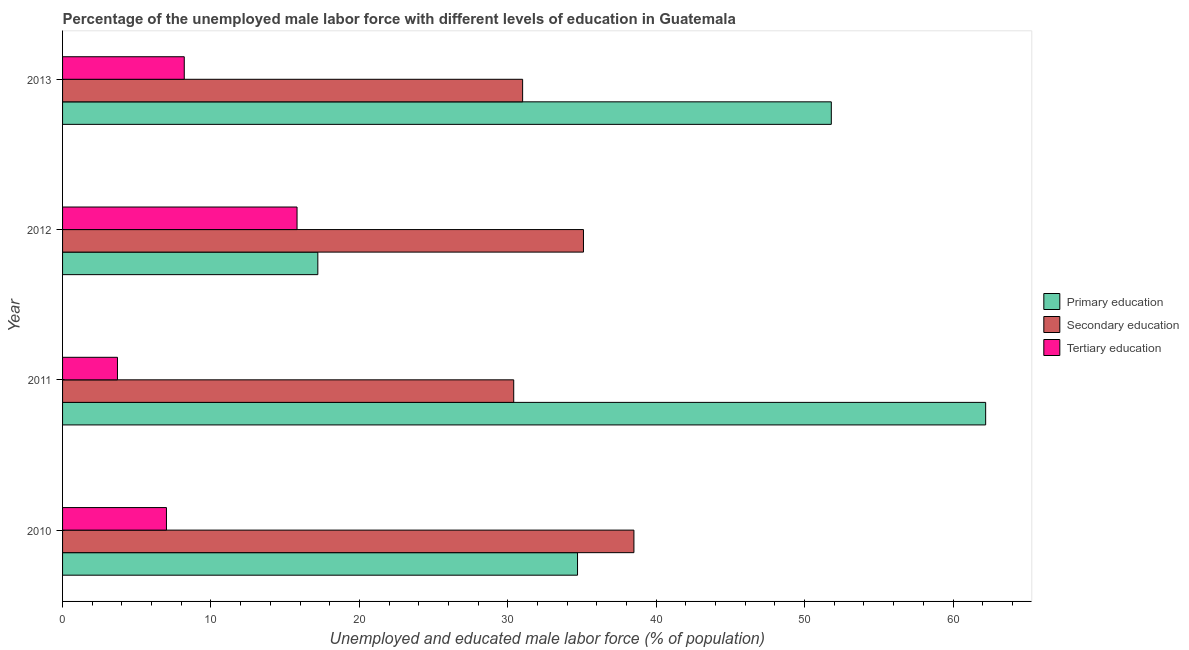How many groups of bars are there?
Offer a terse response. 4. Are the number of bars on each tick of the Y-axis equal?
Offer a very short reply. Yes. How many bars are there on the 1st tick from the bottom?
Ensure brevity in your answer.  3. In how many cases, is the number of bars for a given year not equal to the number of legend labels?
Provide a succinct answer. 0. What is the percentage of male labor force who received secondary education in 2011?
Provide a succinct answer. 30.4. Across all years, what is the maximum percentage of male labor force who received secondary education?
Your response must be concise. 38.5. Across all years, what is the minimum percentage of male labor force who received primary education?
Provide a succinct answer. 17.2. In which year was the percentage of male labor force who received primary education maximum?
Provide a short and direct response. 2011. In which year was the percentage of male labor force who received primary education minimum?
Give a very brief answer. 2012. What is the total percentage of male labor force who received secondary education in the graph?
Your answer should be compact. 135. What is the difference between the percentage of male labor force who received secondary education in 2011 and that in 2013?
Your answer should be very brief. -0.6. What is the difference between the percentage of male labor force who received secondary education in 2011 and the percentage of male labor force who received tertiary education in 2012?
Provide a short and direct response. 14.6. What is the average percentage of male labor force who received primary education per year?
Provide a short and direct response. 41.48. In the year 2013, what is the difference between the percentage of male labor force who received secondary education and percentage of male labor force who received primary education?
Your answer should be compact. -20.8. What is the ratio of the percentage of male labor force who received tertiary education in 2011 to that in 2013?
Keep it short and to the point. 0.45. Is the percentage of male labor force who received secondary education in 2011 less than that in 2013?
Ensure brevity in your answer.  Yes. Is the difference between the percentage of male labor force who received secondary education in 2011 and 2013 greater than the difference between the percentage of male labor force who received primary education in 2011 and 2013?
Give a very brief answer. No. What is the difference between the highest and the second highest percentage of male labor force who received tertiary education?
Provide a succinct answer. 7.6. How many bars are there?
Offer a terse response. 12. How many years are there in the graph?
Offer a terse response. 4. What is the difference between two consecutive major ticks on the X-axis?
Provide a succinct answer. 10. Does the graph contain any zero values?
Provide a succinct answer. No. How many legend labels are there?
Give a very brief answer. 3. What is the title of the graph?
Keep it short and to the point. Percentage of the unemployed male labor force with different levels of education in Guatemala. What is the label or title of the X-axis?
Offer a terse response. Unemployed and educated male labor force (% of population). What is the Unemployed and educated male labor force (% of population) of Primary education in 2010?
Provide a succinct answer. 34.7. What is the Unemployed and educated male labor force (% of population) of Secondary education in 2010?
Offer a terse response. 38.5. What is the Unemployed and educated male labor force (% of population) of Tertiary education in 2010?
Ensure brevity in your answer.  7. What is the Unemployed and educated male labor force (% of population) of Primary education in 2011?
Offer a terse response. 62.2. What is the Unemployed and educated male labor force (% of population) in Secondary education in 2011?
Your answer should be very brief. 30.4. What is the Unemployed and educated male labor force (% of population) of Tertiary education in 2011?
Keep it short and to the point. 3.7. What is the Unemployed and educated male labor force (% of population) of Primary education in 2012?
Offer a terse response. 17.2. What is the Unemployed and educated male labor force (% of population) in Secondary education in 2012?
Offer a very short reply. 35.1. What is the Unemployed and educated male labor force (% of population) in Tertiary education in 2012?
Make the answer very short. 15.8. What is the Unemployed and educated male labor force (% of population) of Primary education in 2013?
Make the answer very short. 51.8. What is the Unemployed and educated male labor force (% of population) in Secondary education in 2013?
Your response must be concise. 31. What is the Unemployed and educated male labor force (% of population) of Tertiary education in 2013?
Ensure brevity in your answer.  8.2. Across all years, what is the maximum Unemployed and educated male labor force (% of population) in Primary education?
Your answer should be very brief. 62.2. Across all years, what is the maximum Unemployed and educated male labor force (% of population) of Secondary education?
Keep it short and to the point. 38.5. Across all years, what is the maximum Unemployed and educated male labor force (% of population) of Tertiary education?
Your response must be concise. 15.8. Across all years, what is the minimum Unemployed and educated male labor force (% of population) in Primary education?
Keep it short and to the point. 17.2. Across all years, what is the minimum Unemployed and educated male labor force (% of population) of Secondary education?
Keep it short and to the point. 30.4. Across all years, what is the minimum Unemployed and educated male labor force (% of population) of Tertiary education?
Give a very brief answer. 3.7. What is the total Unemployed and educated male labor force (% of population) of Primary education in the graph?
Provide a succinct answer. 165.9. What is the total Unemployed and educated male labor force (% of population) of Secondary education in the graph?
Provide a succinct answer. 135. What is the total Unemployed and educated male labor force (% of population) in Tertiary education in the graph?
Offer a very short reply. 34.7. What is the difference between the Unemployed and educated male labor force (% of population) of Primary education in 2010 and that in 2011?
Your answer should be very brief. -27.5. What is the difference between the Unemployed and educated male labor force (% of population) of Secondary education in 2010 and that in 2011?
Ensure brevity in your answer.  8.1. What is the difference between the Unemployed and educated male labor force (% of population) of Primary education in 2010 and that in 2012?
Keep it short and to the point. 17.5. What is the difference between the Unemployed and educated male labor force (% of population) of Secondary education in 2010 and that in 2012?
Offer a very short reply. 3.4. What is the difference between the Unemployed and educated male labor force (% of population) in Tertiary education in 2010 and that in 2012?
Provide a succinct answer. -8.8. What is the difference between the Unemployed and educated male labor force (% of population) in Primary education in 2010 and that in 2013?
Provide a succinct answer. -17.1. What is the difference between the Unemployed and educated male labor force (% of population) of Secondary education in 2010 and that in 2013?
Keep it short and to the point. 7.5. What is the difference between the Unemployed and educated male labor force (% of population) of Primary education in 2011 and that in 2013?
Provide a short and direct response. 10.4. What is the difference between the Unemployed and educated male labor force (% of population) of Secondary education in 2011 and that in 2013?
Make the answer very short. -0.6. What is the difference between the Unemployed and educated male labor force (% of population) in Primary education in 2012 and that in 2013?
Your answer should be compact. -34.6. What is the difference between the Unemployed and educated male labor force (% of population) of Tertiary education in 2012 and that in 2013?
Provide a succinct answer. 7.6. What is the difference between the Unemployed and educated male labor force (% of population) of Primary education in 2010 and the Unemployed and educated male labor force (% of population) of Tertiary education in 2011?
Give a very brief answer. 31. What is the difference between the Unemployed and educated male labor force (% of population) of Secondary education in 2010 and the Unemployed and educated male labor force (% of population) of Tertiary education in 2011?
Give a very brief answer. 34.8. What is the difference between the Unemployed and educated male labor force (% of population) of Primary education in 2010 and the Unemployed and educated male labor force (% of population) of Secondary education in 2012?
Make the answer very short. -0.4. What is the difference between the Unemployed and educated male labor force (% of population) in Primary education in 2010 and the Unemployed and educated male labor force (% of population) in Tertiary education in 2012?
Provide a short and direct response. 18.9. What is the difference between the Unemployed and educated male labor force (% of population) of Secondary education in 2010 and the Unemployed and educated male labor force (% of population) of Tertiary education in 2012?
Your answer should be very brief. 22.7. What is the difference between the Unemployed and educated male labor force (% of population) of Secondary education in 2010 and the Unemployed and educated male labor force (% of population) of Tertiary education in 2013?
Provide a short and direct response. 30.3. What is the difference between the Unemployed and educated male labor force (% of population) in Primary education in 2011 and the Unemployed and educated male labor force (% of population) in Secondary education in 2012?
Your response must be concise. 27.1. What is the difference between the Unemployed and educated male labor force (% of population) of Primary education in 2011 and the Unemployed and educated male labor force (% of population) of Tertiary education in 2012?
Offer a very short reply. 46.4. What is the difference between the Unemployed and educated male labor force (% of population) of Primary education in 2011 and the Unemployed and educated male labor force (% of population) of Secondary education in 2013?
Your answer should be compact. 31.2. What is the difference between the Unemployed and educated male labor force (% of population) of Primary education in 2012 and the Unemployed and educated male labor force (% of population) of Secondary education in 2013?
Offer a terse response. -13.8. What is the difference between the Unemployed and educated male labor force (% of population) of Secondary education in 2012 and the Unemployed and educated male labor force (% of population) of Tertiary education in 2013?
Offer a very short reply. 26.9. What is the average Unemployed and educated male labor force (% of population) of Primary education per year?
Ensure brevity in your answer.  41.48. What is the average Unemployed and educated male labor force (% of population) of Secondary education per year?
Your answer should be very brief. 33.75. What is the average Unemployed and educated male labor force (% of population) in Tertiary education per year?
Provide a short and direct response. 8.68. In the year 2010, what is the difference between the Unemployed and educated male labor force (% of population) in Primary education and Unemployed and educated male labor force (% of population) in Tertiary education?
Ensure brevity in your answer.  27.7. In the year 2010, what is the difference between the Unemployed and educated male labor force (% of population) in Secondary education and Unemployed and educated male labor force (% of population) in Tertiary education?
Ensure brevity in your answer.  31.5. In the year 2011, what is the difference between the Unemployed and educated male labor force (% of population) of Primary education and Unemployed and educated male labor force (% of population) of Secondary education?
Offer a very short reply. 31.8. In the year 2011, what is the difference between the Unemployed and educated male labor force (% of population) of Primary education and Unemployed and educated male labor force (% of population) of Tertiary education?
Provide a succinct answer. 58.5. In the year 2011, what is the difference between the Unemployed and educated male labor force (% of population) of Secondary education and Unemployed and educated male labor force (% of population) of Tertiary education?
Ensure brevity in your answer.  26.7. In the year 2012, what is the difference between the Unemployed and educated male labor force (% of population) of Primary education and Unemployed and educated male labor force (% of population) of Secondary education?
Ensure brevity in your answer.  -17.9. In the year 2012, what is the difference between the Unemployed and educated male labor force (% of population) of Secondary education and Unemployed and educated male labor force (% of population) of Tertiary education?
Offer a terse response. 19.3. In the year 2013, what is the difference between the Unemployed and educated male labor force (% of population) of Primary education and Unemployed and educated male labor force (% of population) of Secondary education?
Offer a very short reply. 20.8. In the year 2013, what is the difference between the Unemployed and educated male labor force (% of population) in Primary education and Unemployed and educated male labor force (% of population) in Tertiary education?
Make the answer very short. 43.6. In the year 2013, what is the difference between the Unemployed and educated male labor force (% of population) in Secondary education and Unemployed and educated male labor force (% of population) in Tertiary education?
Ensure brevity in your answer.  22.8. What is the ratio of the Unemployed and educated male labor force (% of population) of Primary education in 2010 to that in 2011?
Ensure brevity in your answer.  0.56. What is the ratio of the Unemployed and educated male labor force (% of population) of Secondary education in 2010 to that in 2011?
Provide a short and direct response. 1.27. What is the ratio of the Unemployed and educated male labor force (% of population) of Tertiary education in 2010 to that in 2011?
Give a very brief answer. 1.89. What is the ratio of the Unemployed and educated male labor force (% of population) of Primary education in 2010 to that in 2012?
Provide a short and direct response. 2.02. What is the ratio of the Unemployed and educated male labor force (% of population) of Secondary education in 2010 to that in 2012?
Your answer should be very brief. 1.1. What is the ratio of the Unemployed and educated male labor force (% of population) of Tertiary education in 2010 to that in 2012?
Offer a terse response. 0.44. What is the ratio of the Unemployed and educated male labor force (% of population) in Primary education in 2010 to that in 2013?
Keep it short and to the point. 0.67. What is the ratio of the Unemployed and educated male labor force (% of population) of Secondary education in 2010 to that in 2013?
Offer a very short reply. 1.24. What is the ratio of the Unemployed and educated male labor force (% of population) in Tertiary education in 2010 to that in 2013?
Provide a short and direct response. 0.85. What is the ratio of the Unemployed and educated male labor force (% of population) in Primary education in 2011 to that in 2012?
Keep it short and to the point. 3.62. What is the ratio of the Unemployed and educated male labor force (% of population) of Secondary education in 2011 to that in 2012?
Ensure brevity in your answer.  0.87. What is the ratio of the Unemployed and educated male labor force (% of population) of Tertiary education in 2011 to that in 2012?
Offer a very short reply. 0.23. What is the ratio of the Unemployed and educated male labor force (% of population) in Primary education in 2011 to that in 2013?
Your answer should be compact. 1.2. What is the ratio of the Unemployed and educated male labor force (% of population) in Secondary education in 2011 to that in 2013?
Give a very brief answer. 0.98. What is the ratio of the Unemployed and educated male labor force (% of population) in Tertiary education in 2011 to that in 2013?
Your answer should be compact. 0.45. What is the ratio of the Unemployed and educated male labor force (% of population) of Primary education in 2012 to that in 2013?
Your answer should be very brief. 0.33. What is the ratio of the Unemployed and educated male labor force (% of population) in Secondary education in 2012 to that in 2013?
Your answer should be very brief. 1.13. What is the ratio of the Unemployed and educated male labor force (% of population) in Tertiary education in 2012 to that in 2013?
Provide a short and direct response. 1.93. What is the difference between the highest and the second highest Unemployed and educated male labor force (% of population) of Secondary education?
Your answer should be compact. 3.4. What is the difference between the highest and the lowest Unemployed and educated male labor force (% of population) of Primary education?
Offer a terse response. 45. What is the difference between the highest and the lowest Unemployed and educated male labor force (% of population) in Tertiary education?
Offer a very short reply. 12.1. 